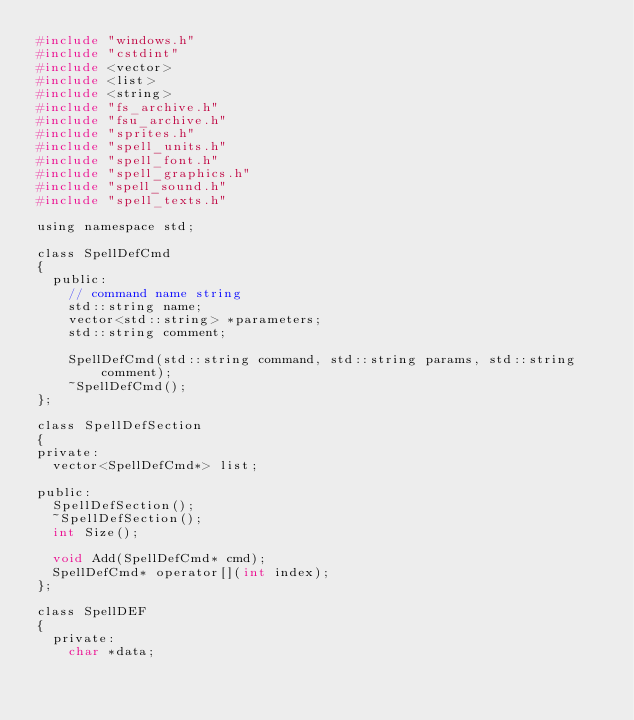<code> <loc_0><loc_0><loc_500><loc_500><_C_>#include "windows.h"
#include "cstdint"
#include <vector>
#include <list>
#include <string>
#include "fs_archive.h"
#include "fsu_archive.h"
#include "sprites.h"
#include "spell_units.h"
#include "spell_font.h"
#include "spell_graphics.h"
#include "spell_sound.h"
#include "spell_texts.h"

using namespace std;

class SpellDefCmd
{
	public:
		// command name string
		std::string name;		
		vector<std::string> *parameters;
		std::string comment;

		SpellDefCmd(std::string command, std::string params, std::string comment);
		~SpellDefCmd();
};

class SpellDefSection
{
private:
	vector<SpellDefCmd*> list;

public:
	SpellDefSection();
	~SpellDefSection();
	int Size();

	void Add(SpellDefCmd* cmd);
	SpellDefCmd* operator[](int index);
};

class SpellDEF
{
	private: 
		char *data;
</code> 